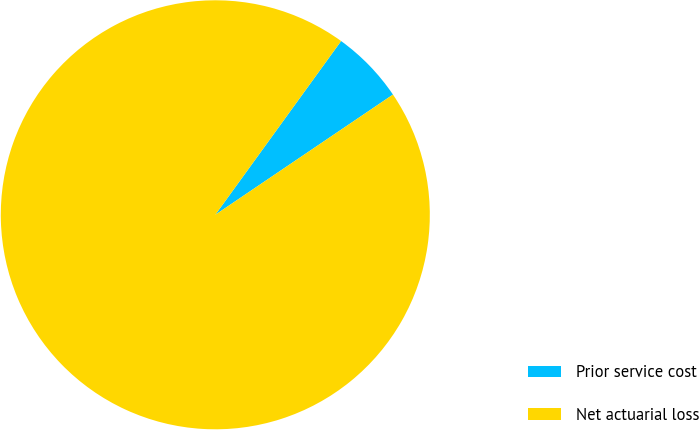Convert chart. <chart><loc_0><loc_0><loc_500><loc_500><pie_chart><fcel>Prior service cost<fcel>Net actuarial loss<nl><fcel>5.56%<fcel>94.44%<nl></chart> 